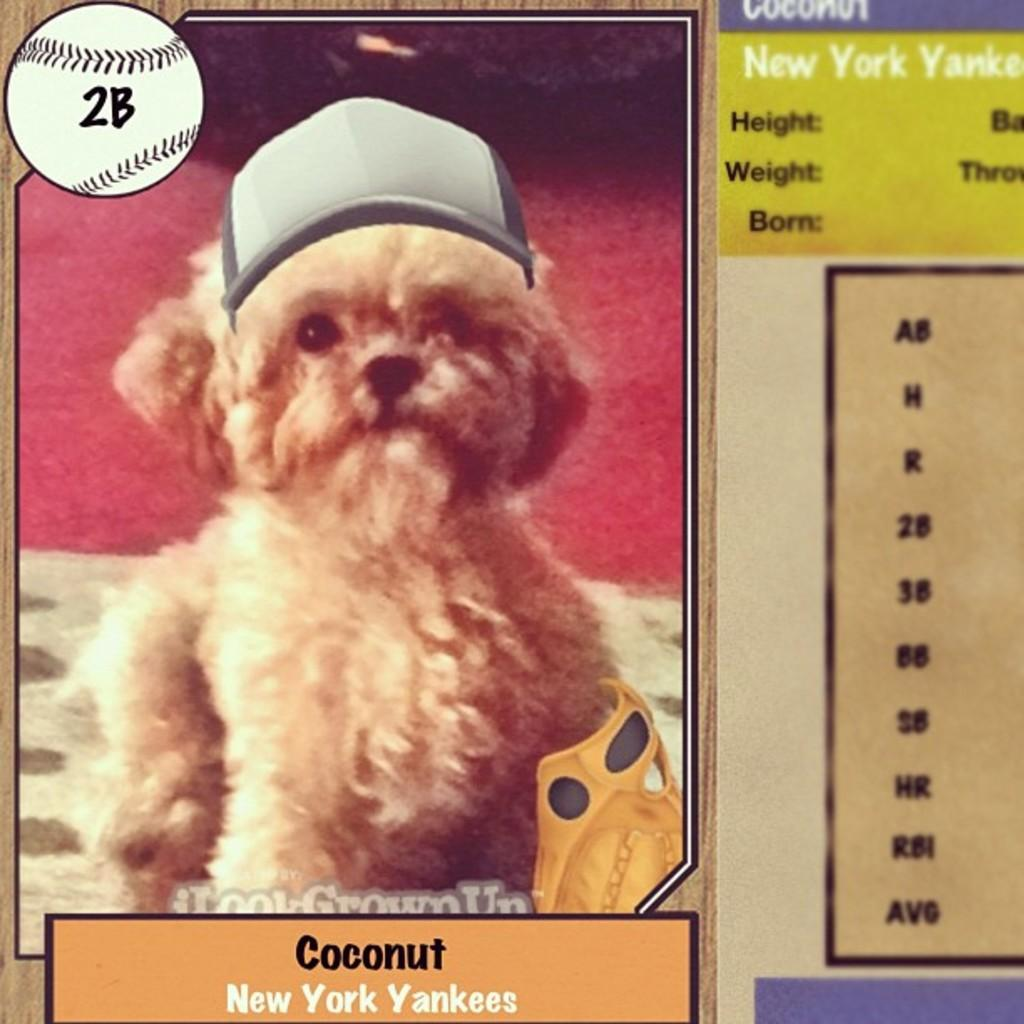What is the main subject of the poster in the image? The poster features a teddy bear toy. What else is included on the poster besides the teddy bear? The poster includes a bed sheet. Is there any text or writing on the poster? Yes, there is some matter written on the poster. What type of growth can be observed on the teddy bear in the image? There is no growth visible on the teddy bear in the image, as it is a static image of a toy. What observation can be made about the sink in the image? There is no sink present in the image; it only features a poster with a teddy bear toy and a bed sheet. 